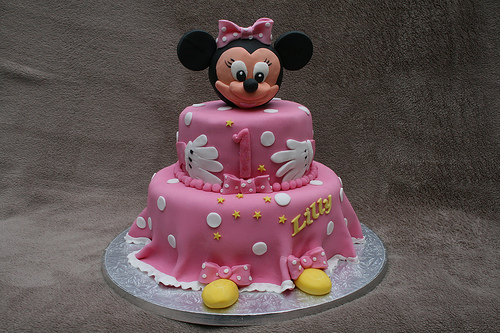<image>
Can you confirm if the cake is behind the cloth? No. The cake is not behind the cloth. From this viewpoint, the cake appears to be positioned elsewhere in the scene. 